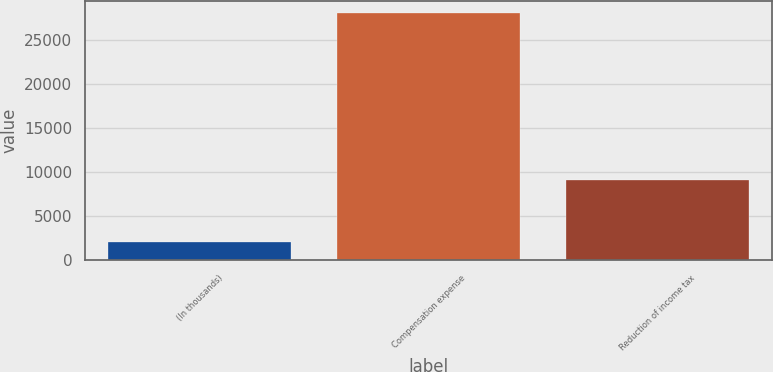Convert chart to OTSL. <chart><loc_0><loc_0><loc_500><loc_500><bar_chart><fcel>(In thousands)<fcel>Compensation expense<fcel>Reduction of income tax<nl><fcel>2013<fcel>28052<fcel>9123<nl></chart> 